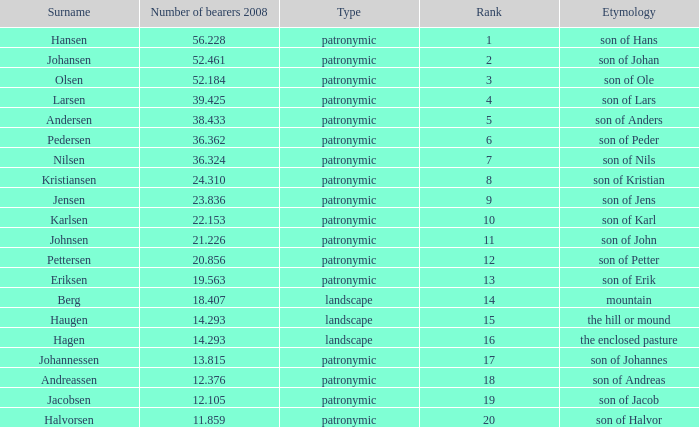What is Etymology, when Rank is 14? Mountain. 